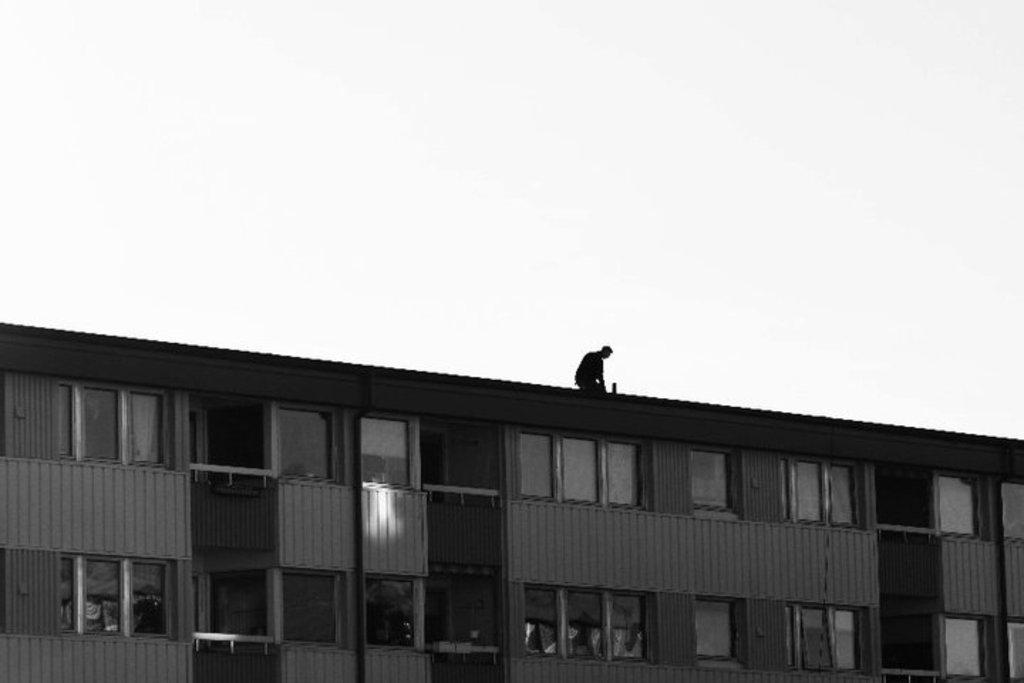Who is present in the image? There is a man in the image. Where is the man located? The man is on a building. What is a notable feature of the building? The building has glass windows. What color scheme is used in the image? The image is in black and white color. What type of beef is being delivered to the man in the image? There is no beef or delivery mentioned in the image; it only features a man on a building with glass windows. 